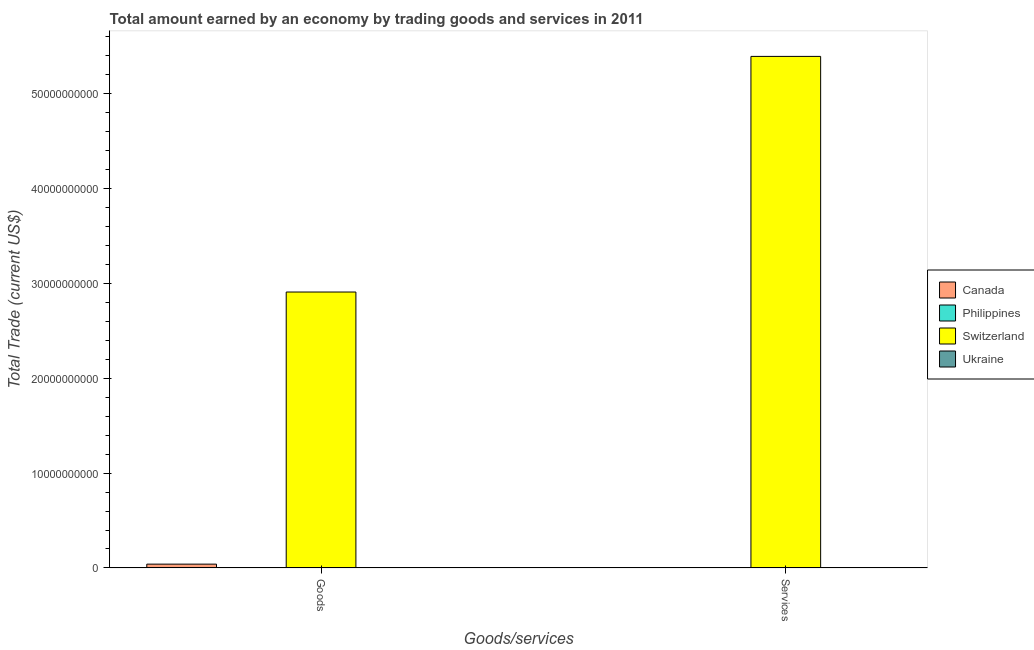Are the number of bars on each tick of the X-axis equal?
Your response must be concise. No. What is the label of the 1st group of bars from the left?
Make the answer very short. Goods. What is the amount earned by trading goods in Canada?
Ensure brevity in your answer.  4.03e+08. Across all countries, what is the maximum amount earned by trading goods?
Your response must be concise. 2.91e+1. Across all countries, what is the minimum amount earned by trading services?
Offer a terse response. 0. In which country was the amount earned by trading services maximum?
Keep it short and to the point. Switzerland. What is the total amount earned by trading goods in the graph?
Offer a very short reply. 2.95e+1. What is the difference between the amount earned by trading goods in Canada and that in Switzerland?
Offer a very short reply. -2.87e+1. What is the difference between the amount earned by trading services in Philippines and the amount earned by trading goods in Switzerland?
Make the answer very short. -2.91e+1. What is the average amount earned by trading services per country?
Provide a short and direct response. 1.35e+1. What is the difference between the amount earned by trading goods and amount earned by trading services in Switzerland?
Your answer should be compact. -2.48e+1. In how many countries, is the amount earned by trading goods greater than 8000000000 US$?
Make the answer very short. 1. What is the ratio of the amount earned by trading goods in Switzerland to that in Canada?
Your answer should be very brief. 72.12. Are the values on the major ticks of Y-axis written in scientific E-notation?
Provide a succinct answer. No. Where does the legend appear in the graph?
Offer a very short reply. Center right. How many legend labels are there?
Keep it short and to the point. 4. What is the title of the graph?
Provide a short and direct response. Total amount earned by an economy by trading goods and services in 2011. Does "Egypt, Arab Rep." appear as one of the legend labels in the graph?
Keep it short and to the point. No. What is the label or title of the X-axis?
Offer a very short reply. Goods/services. What is the label or title of the Y-axis?
Keep it short and to the point. Total Trade (current US$). What is the Total Trade (current US$) of Canada in Goods?
Offer a terse response. 4.03e+08. What is the Total Trade (current US$) of Philippines in Goods?
Provide a short and direct response. 0. What is the Total Trade (current US$) of Switzerland in Goods?
Your answer should be compact. 2.91e+1. What is the Total Trade (current US$) in Ukraine in Goods?
Give a very brief answer. 0. What is the Total Trade (current US$) of Canada in Services?
Make the answer very short. 0. What is the Total Trade (current US$) of Switzerland in Services?
Your response must be concise. 5.39e+1. What is the Total Trade (current US$) of Ukraine in Services?
Your response must be concise. 0. Across all Goods/services, what is the maximum Total Trade (current US$) of Canada?
Your answer should be compact. 4.03e+08. Across all Goods/services, what is the maximum Total Trade (current US$) in Switzerland?
Your answer should be very brief. 5.39e+1. Across all Goods/services, what is the minimum Total Trade (current US$) of Canada?
Ensure brevity in your answer.  0. Across all Goods/services, what is the minimum Total Trade (current US$) in Switzerland?
Your answer should be compact. 2.91e+1. What is the total Total Trade (current US$) of Canada in the graph?
Your answer should be very brief. 4.03e+08. What is the total Total Trade (current US$) in Switzerland in the graph?
Your response must be concise. 8.30e+1. What is the difference between the Total Trade (current US$) of Switzerland in Goods and that in Services?
Your response must be concise. -2.48e+1. What is the difference between the Total Trade (current US$) of Canada in Goods and the Total Trade (current US$) of Switzerland in Services?
Provide a short and direct response. -5.35e+1. What is the average Total Trade (current US$) of Canada per Goods/services?
Your answer should be compact. 2.02e+08. What is the average Total Trade (current US$) of Philippines per Goods/services?
Provide a succinct answer. 0. What is the average Total Trade (current US$) of Switzerland per Goods/services?
Your response must be concise. 4.15e+1. What is the difference between the Total Trade (current US$) of Canada and Total Trade (current US$) of Switzerland in Goods?
Offer a terse response. -2.87e+1. What is the ratio of the Total Trade (current US$) in Switzerland in Goods to that in Services?
Provide a succinct answer. 0.54. What is the difference between the highest and the second highest Total Trade (current US$) in Switzerland?
Your answer should be very brief. 2.48e+1. What is the difference between the highest and the lowest Total Trade (current US$) of Canada?
Your answer should be compact. 4.03e+08. What is the difference between the highest and the lowest Total Trade (current US$) of Switzerland?
Ensure brevity in your answer.  2.48e+1. 